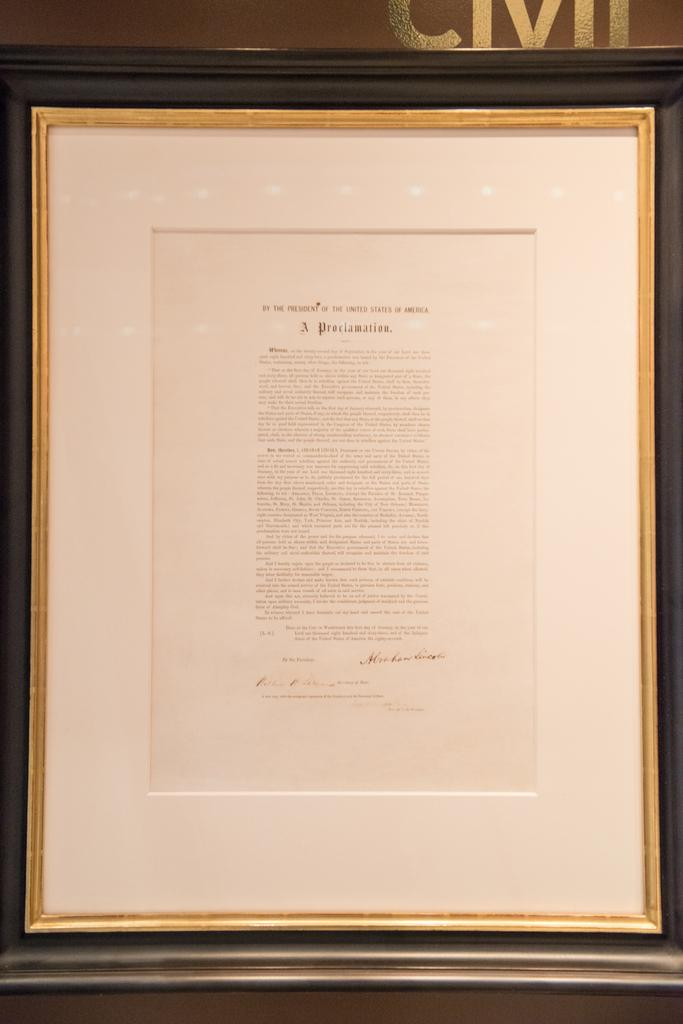Provide a one-sentence caption for the provided image. A framed document that says A Proclamation on it. 